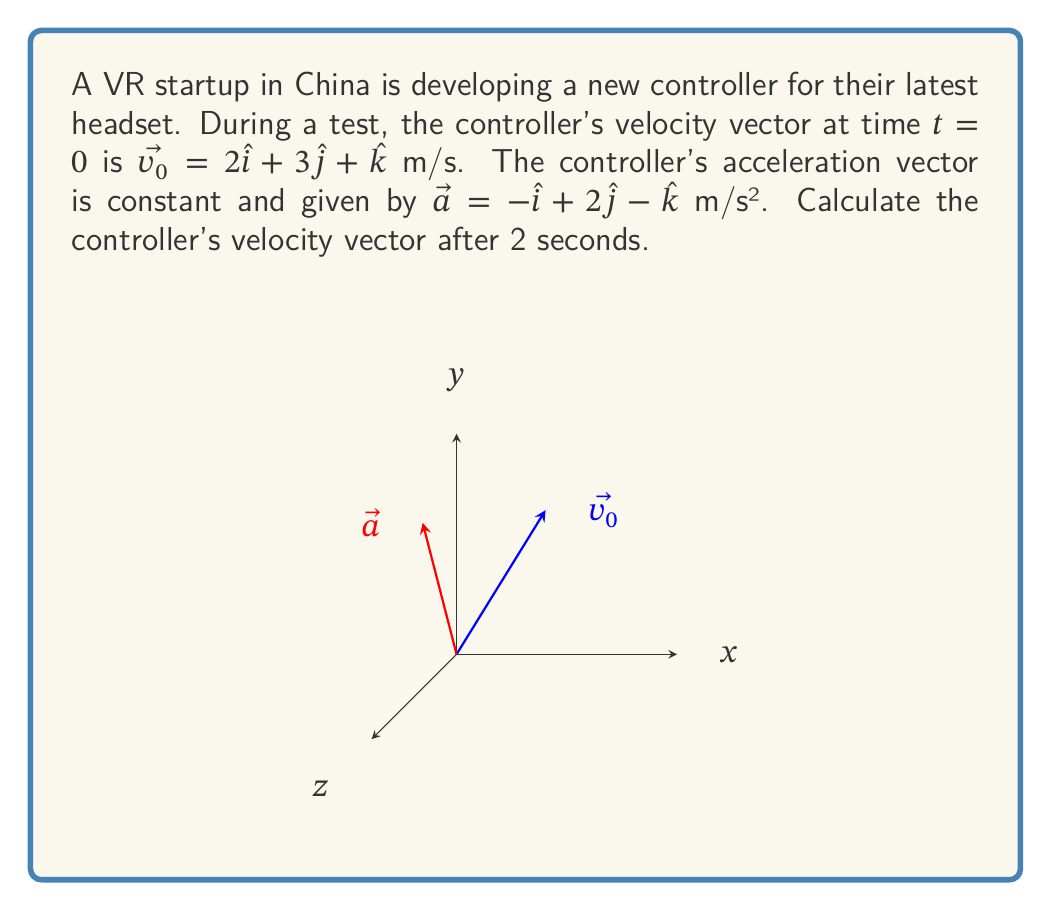Show me your answer to this math problem. To solve this problem, we'll use the equation for velocity under constant acceleration:

$$\vec{v} = \vec{v_0} + \vec{a}t$$

Where:
$\vec{v}$ is the final velocity vector
$\vec{v_0}$ is the initial velocity vector
$\vec{a}$ is the acceleration vector
$t$ is the time elapsed

Given:
$\vec{v_0} = 2\hat{i} + 3\hat{j} + \hat{k}$ m/s
$\vec{a} = -\hat{i} + 2\hat{j} - \hat{k}$ m/s²
$t = 2$ seconds

Let's substitute these values into the equation:

$$\vec{v} = (2\hat{i} + 3\hat{j} + \hat{k}) + (-\hat{i} + 2\hat{j} - \hat{k})(2)$$

Now, let's distribute the scalar 2:

$$\vec{v} = (2\hat{i} + 3\hat{j} + \hat{k}) + (-2\hat{i} + 4\hat{j} - 2\hat{k})$$

Finally, we can add the corresponding components:

$$\vec{v} = (2-2)\hat{i} + (3+4)\hat{j} + (1-2)\hat{k}$$

Simplifying:

$$\vec{v} = 0\hat{i} + 7\hat{j} - \hat{k}$$

This is the velocity vector of the VR controller after 2 seconds.
Answer: $\vec{v} = 7\hat{j} - \hat{k}$ m/s 